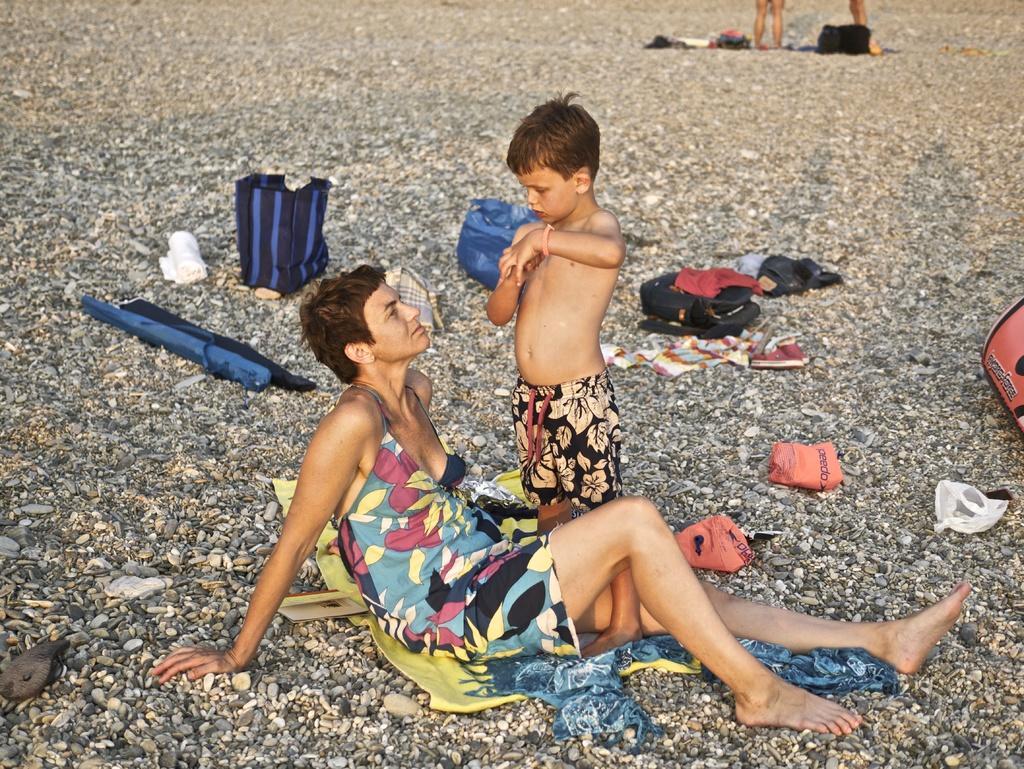Can you describe this image briefly? In this picture there is a lady and a small boy in the center of the image, on the pebbles floor. 